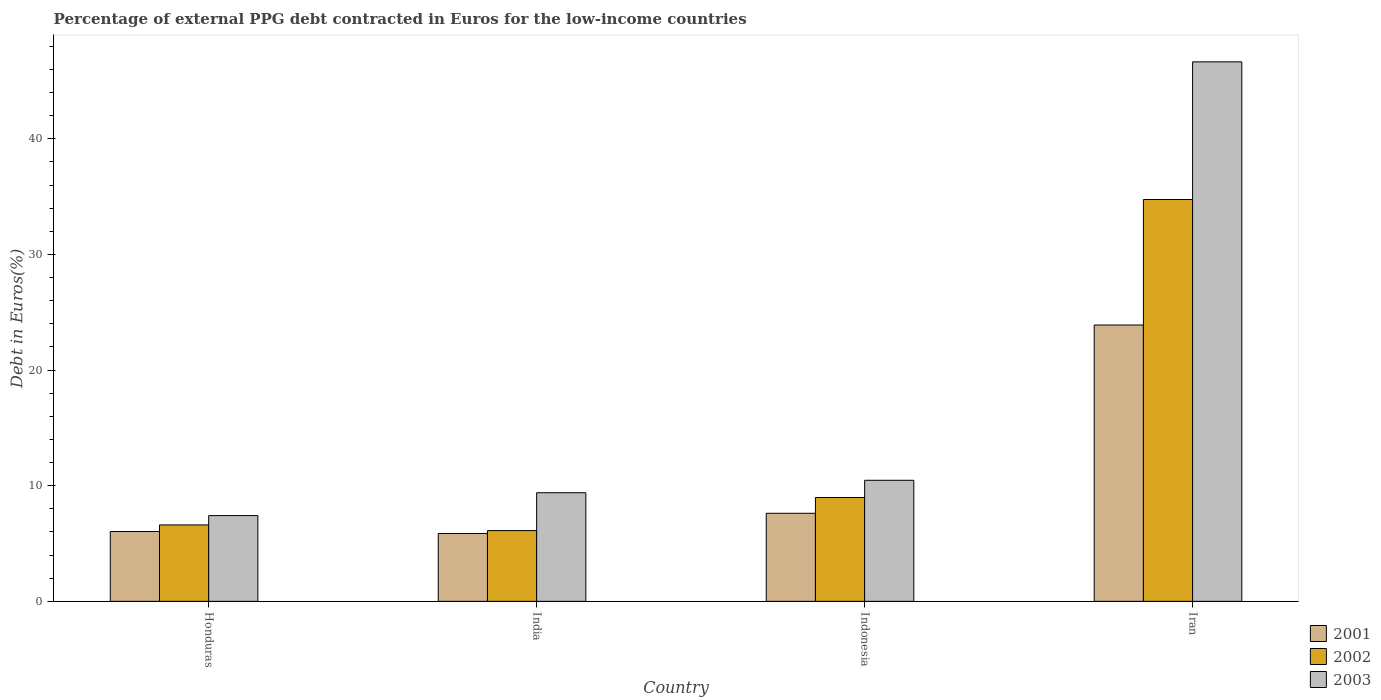How many different coloured bars are there?
Give a very brief answer. 3. Are the number of bars per tick equal to the number of legend labels?
Offer a terse response. Yes. How many bars are there on the 3rd tick from the right?
Your answer should be compact. 3. In how many cases, is the number of bars for a given country not equal to the number of legend labels?
Give a very brief answer. 0. What is the percentage of external PPG debt contracted in Euros in 2001 in Honduras?
Your answer should be compact. 6.04. Across all countries, what is the maximum percentage of external PPG debt contracted in Euros in 2002?
Your answer should be very brief. 34.75. Across all countries, what is the minimum percentage of external PPG debt contracted in Euros in 2003?
Your answer should be compact. 7.42. In which country was the percentage of external PPG debt contracted in Euros in 2003 maximum?
Offer a very short reply. Iran. What is the total percentage of external PPG debt contracted in Euros in 2003 in the graph?
Make the answer very short. 73.93. What is the difference between the percentage of external PPG debt contracted in Euros in 2002 in Honduras and that in Indonesia?
Your answer should be very brief. -2.37. What is the difference between the percentage of external PPG debt contracted in Euros in 2001 in Indonesia and the percentage of external PPG debt contracted in Euros in 2002 in Iran?
Make the answer very short. -27.14. What is the average percentage of external PPG debt contracted in Euros in 2003 per country?
Offer a very short reply. 18.48. What is the difference between the percentage of external PPG debt contracted in Euros of/in 2002 and percentage of external PPG debt contracted in Euros of/in 2001 in India?
Keep it short and to the point. 0.25. What is the ratio of the percentage of external PPG debt contracted in Euros in 2001 in Honduras to that in Indonesia?
Offer a terse response. 0.79. Is the percentage of external PPG debt contracted in Euros in 2003 in Honduras less than that in India?
Ensure brevity in your answer.  Yes. What is the difference between the highest and the second highest percentage of external PPG debt contracted in Euros in 2003?
Provide a succinct answer. -1.08. What is the difference between the highest and the lowest percentage of external PPG debt contracted in Euros in 2003?
Ensure brevity in your answer.  39.24. What does the 3rd bar from the left in Honduras represents?
Your answer should be compact. 2003. How many bars are there?
Your answer should be very brief. 12. Are all the bars in the graph horizontal?
Offer a very short reply. No. How many countries are there in the graph?
Give a very brief answer. 4. What is the difference between two consecutive major ticks on the Y-axis?
Your response must be concise. 10. Does the graph contain any zero values?
Give a very brief answer. No. How are the legend labels stacked?
Ensure brevity in your answer.  Vertical. What is the title of the graph?
Ensure brevity in your answer.  Percentage of external PPG debt contracted in Euros for the low-income countries. Does "1994" appear as one of the legend labels in the graph?
Offer a terse response. No. What is the label or title of the Y-axis?
Give a very brief answer. Debt in Euros(%). What is the Debt in Euros(%) in 2001 in Honduras?
Offer a very short reply. 6.04. What is the Debt in Euros(%) of 2002 in Honduras?
Your response must be concise. 6.61. What is the Debt in Euros(%) of 2003 in Honduras?
Provide a short and direct response. 7.42. What is the Debt in Euros(%) in 2001 in India?
Provide a succinct answer. 5.87. What is the Debt in Euros(%) in 2002 in India?
Ensure brevity in your answer.  6.12. What is the Debt in Euros(%) of 2003 in India?
Ensure brevity in your answer.  9.39. What is the Debt in Euros(%) in 2001 in Indonesia?
Ensure brevity in your answer.  7.62. What is the Debt in Euros(%) of 2002 in Indonesia?
Make the answer very short. 8.98. What is the Debt in Euros(%) in 2003 in Indonesia?
Give a very brief answer. 10.47. What is the Debt in Euros(%) of 2001 in Iran?
Your response must be concise. 23.9. What is the Debt in Euros(%) of 2002 in Iran?
Provide a succinct answer. 34.75. What is the Debt in Euros(%) of 2003 in Iran?
Provide a succinct answer. 46.66. Across all countries, what is the maximum Debt in Euros(%) in 2001?
Your response must be concise. 23.9. Across all countries, what is the maximum Debt in Euros(%) in 2002?
Offer a terse response. 34.75. Across all countries, what is the maximum Debt in Euros(%) of 2003?
Offer a terse response. 46.66. Across all countries, what is the minimum Debt in Euros(%) in 2001?
Keep it short and to the point. 5.87. Across all countries, what is the minimum Debt in Euros(%) in 2002?
Your response must be concise. 6.12. Across all countries, what is the minimum Debt in Euros(%) in 2003?
Give a very brief answer. 7.42. What is the total Debt in Euros(%) of 2001 in the graph?
Provide a short and direct response. 43.42. What is the total Debt in Euros(%) of 2002 in the graph?
Give a very brief answer. 56.46. What is the total Debt in Euros(%) in 2003 in the graph?
Offer a very short reply. 73.93. What is the difference between the Debt in Euros(%) in 2001 in Honduras and that in India?
Ensure brevity in your answer.  0.17. What is the difference between the Debt in Euros(%) of 2002 in Honduras and that in India?
Ensure brevity in your answer.  0.49. What is the difference between the Debt in Euros(%) in 2003 in Honduras and that in India?
Give a very brief answer. -1.98. What is the difference between the Debt in Euros(%) in 2001 in Honduras and that in Indonesia?
Provide a short and direct response. -1.58. What is the difference between the Debt in Euros(%) in 2002 in Honduras and that in Indonesia?
Your answer should be compact. -2.37. What is the difference between the Debt in Euros(%) in 2003 in Honduras and that in Indonesia?
Your answer should be compact. -3.05. What is the difference between the Debt in Euros(%) of 2001 in Honduras and that in Iran?
Provide a short and direct response. -17.86. What is the difference between the Debt in Euros(%) in 2002 in Honduras and that in Iran?
Ensure brevity in your answer.  -28.14. What is the difference between the Debt in Euros(%) in 2003 in Honduras and that in Iran?
Your answer should be compact. -39.24. What is the difference between the Debt in Euros(%) of 2001 in India and that in Indonesia?
Give a very brief answer. -1.75. What is the difference between the Debt in Euros(%) of 2002 in India and that in Indonesia?
Keep it short and to the point. -2.86. What is the difference between the Debt in Euros(%) in 2003 in India and that in Indonesia?
Keep it short and to the point. -1.08. What is the difference between the Debt in Euros(%) of 2001 in India and that in Iran?
Ensure brevity in your answer.  -18.03. What is the difference between the Debt in Euros(%) of 2002 in India and that in Iran?
Provide a succinct answer. -28.63. What is the difference between the Debt in Euros(%) in 2003 in India and that in Iran?
Ensure brevity in your answer.  -37.26. What is the difference between the Debt in Euros(%) in 2001 in Indonesia and that in Iran?
Keep it short and to the point. -16.28. What is the difference between the Debt in Euros(%) of 2002 in Indonesia and that in Iran?
Provide a succinct answer. -25.77. What is the difference between the Debt in Euros(%) in 2003 in Indonesia and that in Iran?
Your answer should be very brief. -36.19. What is the difference between the Debt in Euros(%) in 2001 in Honduras and the Debt in Euros(%) in 2002 in India?
Offer a terse response. -0.08. What is the difference between the Debt in Euros(%) of 2001 in Honduras and the Debt in Euros(%) of 2003 in India?
Keep it short and to the point. -3.36. What is the difference between the Debt in Euros(%) of 2002 in Honduras and the Debt in Euros(%) of 2003 in India?
Give a very brief answer. -2.78. What is the difference between the Debt in Euros(%) in 2001 in Honduras and the Debt in Euros(%) in 2002 in Indonesia?
Ensure brevity in your answer.  -2.94. What is the difference between the Debt in Euros(%) of 2001 in Honduras and the Debt in Euros(%) of 2003 in Indonesia?
Your answer should be compact. -4.43. What is the difference between the Debt in Euros(%) in 2002 in Honduras and the Debt in Euros(%) in 2003 in Indonesia?
Ensure brevity in your answer.  -3.86. What is the difference between the Debt in Euros(%) in 2001 in Honduras and the Debt in Euros(%) in 2002 in Iran?
Provide a short and direct response. -28.71. What is the difference between the Debt in Euros(%) of 2001 in Honduras and the Debt in Euros(%) of 2003 in Iran?
Offer a very short reply. -40.62. What is the difference between the Debt in Euros(%) of 2002 in Honduras and the Debt in Euros(%) of 2003 in Iran?
Ensure brevity in your answer.  -40.05. What is the difference between the Debt in Euros(%) in 2001 in India and the Debt in Euros(%) in 2002 in Indonesia?
Make the answer very short. -3.11. What is the difference between the Debt in Euros(%) in 2001 in India and the Debt in Euros(%) in 2003 in Indonesia?
Offer a terse response. -4.6. What is the difference between the Debt in Euros(%) in 2002 in India and the Debt in Euros(%) in 2003 in Indonesia?
Provide a short and direct response. -4.35. What is the difference between the Debt in Euros(%) in 2001 in India and the Debt in Euros(%) in 2002 in Iran?
Give a very brief answer. -28.88. What is the difference between the Debt in Euros(%) of 2001 in India and the Debt in Euros(%) of 2003 in Iran?
Give a very brief answer. -40.78. What is the difference between the Debt in Euros(%) in 2002 in India and the Debt in Euros(%) in 2003 in Iran?
Your response must be concise. -40.54. What is the difference between the Debt in Euros(%) of 2001 in Indonesia and the Debt in Euros(%) of 2002 in Iran?
Provide a succinct answer. -27.14. What is the difference between the Debt in Euros(%) in 2001 in Indonesia and the Debt in Euros(%) in 2003 in Iran?
Keep it short and to the point. -39.04. What is the difference between the Debt in Euros(%) of 2002 in Indonesia and the Debt in Euros(%) of 2003 in Iran?
Provide a short and direct response. -37.67. What is the average Debt in Euros(%) in 2001 per country?
Provide a succinct answer. 10.86. What is the average Debt in Euros(%) in 2002 per country?
Make the answer very short. 14.12. What is the average Debt in Euros(%) in 2003 per country?
Offer a terse response. 18.48. What is the difference between the Debt in Euros(%) of 2001 and Debt in Euros(%) of 2002 in Honduras?
Make the answer very short. -0.57. What is the difference between the Debt in Euros(%) in 2001 and Debt in Euros(%) in 2003 in Honduras?
Offer a very short reply. -1.38. What is the difference between the Debt in Euros(%) of 2002 and Debt in Euros(%) of 2003 in Honduras?
Ensure brevity in your answer.  -0.81. What is the difference between the Debt in Euros(%) of 2001 and Debt in Euros(%) of 2002 in India?
Your answer should be compact. -0.25. What is the difference between the Debt in Euros(%) in 2001 and Debt in Euros(%) in 2003 in India?
Offer a very short reply. -3.52. What is the difference between the Debt in Euros(%) of 2002 and Debt in Euros(%) of 2003 in India?
Your answer should be very brief. -3.27. What is the difference between the Debt in Euros(%) in 2001 and Debt in Euros(%) in 2002 in Indonesia?
Your answer should be compact. -1.37. What is the difference between the Debt in Euros(%) in 2001 and Debt in Euros(%) in 2003 in Indonesia?
Your answer should be compact. -2.85. What is the difference between the Debt in Euros(%) of 2002 and Debt in Euros(%) of 2003 in Indonesia?
Keep it short and to the point. -1.49. What is the difference between the Debt in Euros(%) in 2001 and Debt in Euros(%) in 2002 in Iran?
Your answer should be very brief. -10.85. What is the difference between the Debt in Euros(%) of 2001 and Debt in Euros(%) of 2003 in Iran?
Your answer should be very brief. -22.76. What is the difference between the Debt in Euros(%) of 2002 and Debt in Euros(%) of 2003 in Iran?
Make the answer very short. -11.9. What is the ratio of the Debt in Euros(%) in 2001 in Honduras to that in India?
Provide a short and direct response. 1.03. What is the ratio of the Debt in Euros(%) in 2002 in Honduras to that in India?
Your answer should be very brief. 1.08. What is the ratio of the Debt in Euros(%) of 2003 in Honduras to that in India?
Your answer should be compact. 0.79. What is the ratio of the Debt in Euros(%) of 2001 in Honduras to that in Indonesia?
Offer a terse response. 0.79. What is the ratio of the Debt in Euros(%) of 2002 in Honduras to that in Indonesia?
Keep it short and to the point. 0.74. What is the ratio of the Debt in Euros(%) of 2003 in Honduras to that in Indonesia?
Offer a terse response. 0.71. What is the ratio of the Debt in Euros(%) of 2001 in Honduras to that in Iran?
Your response must be concise. 0.25. What is the ratio of the Debt in Euros(%) of 2002 in Honduras to that in Iran?
Provide a short and direct response. 0.19. What is the ratio of the Debt in Euros(%) in 2003 in Honduras to that in Iran?
Keep it short and to the point. 0.16. What is the ratio of the Debt in Euros(%) in 2001 in India to that in Indonesia?
Your response must be concise. 0.77. What is the ratio of the Debt in Euros(%) in 2002 in India to that in Indonesia?
Offer a very short reply. 0.68. What is the ratio of the Debt in Euros(%) in 2003 in India to that in Indonesia?
Provide a short and direct response. 0.9. What is the ratio of the Debt in Euros(%) of 2001 in India to that in Iran?
Provide a short and direct response. 0.25. What is the ratio of the Debt in Euros(%) in 2002 in India to that in Iran?
Provide a succinct answer. 0.18. What is the ratio of the Debt in Euros(%) of 2003 in India to that in Iran?
Offer a terse response. 0.2. What is the ratio of the Debt in Euros(%) of 2001 in Indonesia to that in Iran?
Make the answer very short. 0.32. What is the ratio of the Debt in Euros(%) of 2002 in Indonesia to that in Iran?
Your answer should be compact. 0.26. What is the ratio of the Debt in Euros(%) in 2003 in Indonesia to that in Iran?
Provide a succinct answer. 0.22. What is the difference between the highest and the second highest Debt in Euros(%) of 2001?
Provide a short and direct response. 16.28. What is the difference between the highest and the second highest Debt in Euros(%) in 2002?
Your answer should be very brief. 25.77. What is the difference between the highest and the second highest Debt in Euros(%) in 2003?
Keep it short and to the point. 36.19. What is the difference between the highest and the lowest Debt in Euros(%) of 2001?
Offer a terse response. 18.03. What is the difference between the highest and the lowest Debt in Euros(%) of 2002?
Give a very brief answer. 28.63. What is the difference between the highest and the lowest Debt in Euros(%) of 2003?
Offer a very short reply. 39.24. 